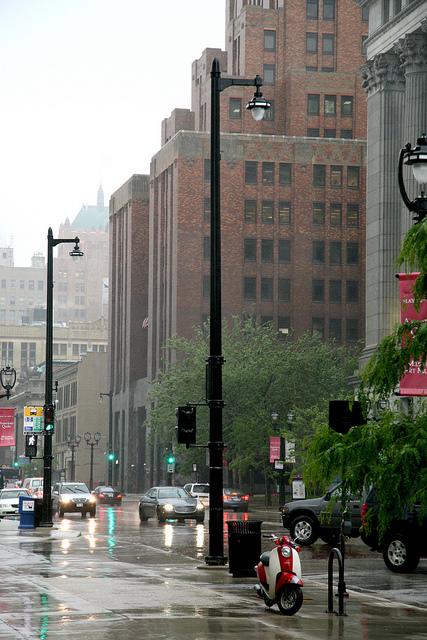How many inches did it rain?
Keep it brief. 1. What color are the light post?
Keep it brief. Black. Is it sunny?
Give a very brief answer. No. 